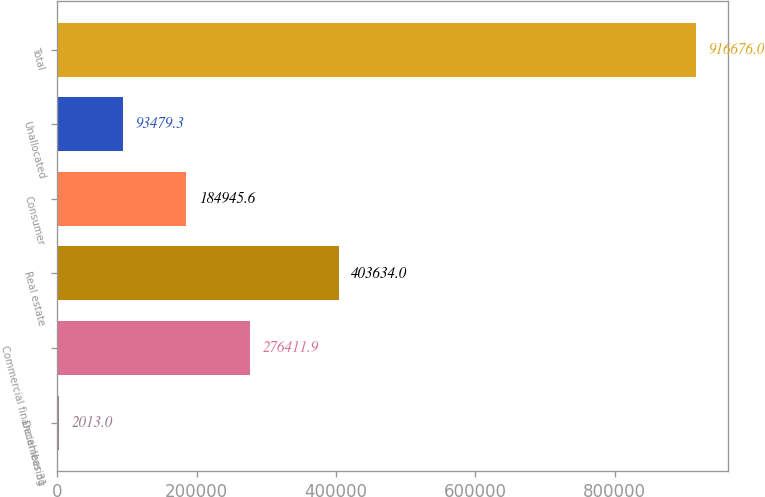Convert chart to OTSL. <chart><loc_0><loc_0><loc_500><loc_500><bar_chart><fcel>December 31<fcel>Commercial financial leasing<fcel>Real estate<fcel>Consumer<fcel>Unallocated<fcel>Total<nl><fcel>2013<fcel>276412<fcel>403634<fcel>184946<fcel>93479.3<fcel>916676<nl></chart> 